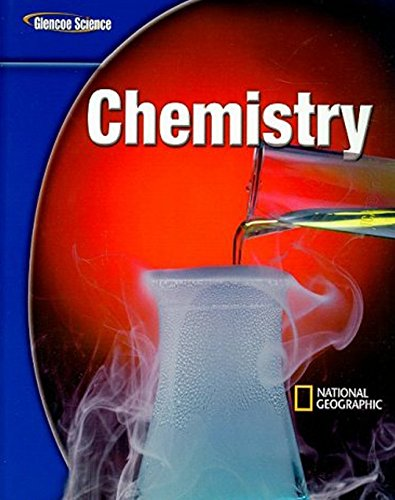Is this book related to Children's Books? No, this book is not categorized under Children's Books; it is an educational textbook intended for middle school science education, specifically chemistry. 